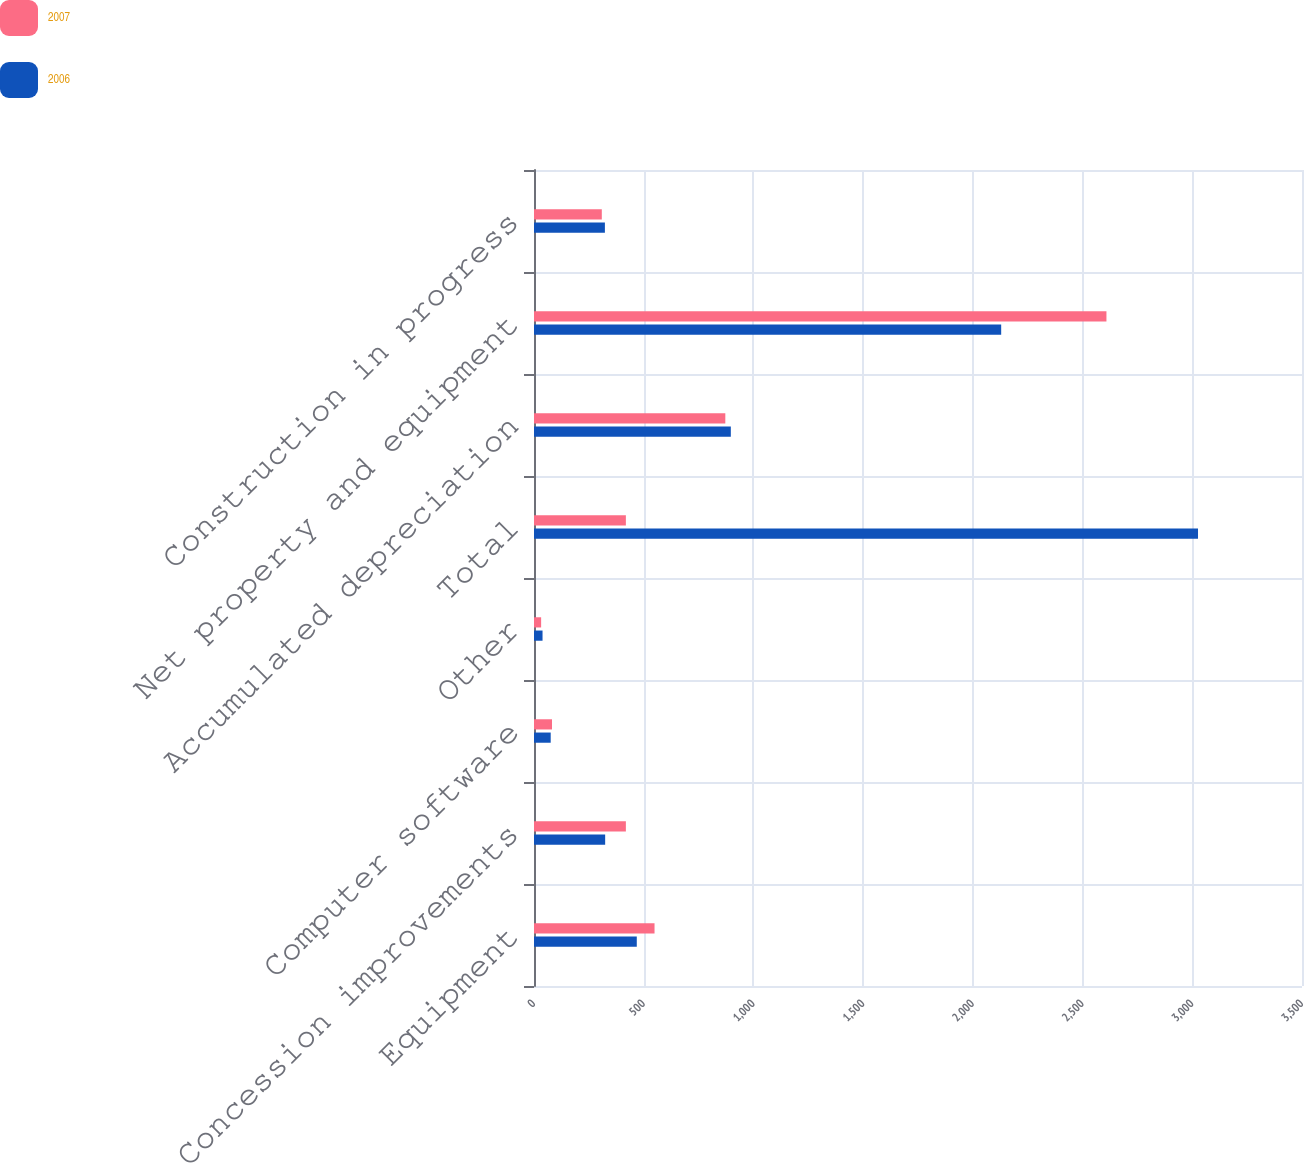<chart> <loc_0><loc_0><loc_500><loc_500><stacked_bar_chart><ecel><fcel>Equipment<fcel>Concession improvements<fcel>Computer software<fcel>Other<fcel>Total<fcel>Accumulated depreciation<fcel>Net property and equipment<fcel>Construction in progress<nl><fcel>2007<fcel>549.3<fcel>418.7<fcel>82.1<fcel>32.5<fcel>418.7<fcel>871.9<fcel>2608.8<fcel>309<nl><fcel>2006<fcel>468.4<fcel>324.3<fcel>76.1<fcel>38.9<fcel>3026.1<fcel>897<fcel>2129.1<fcel>323.1<nl></chart> 